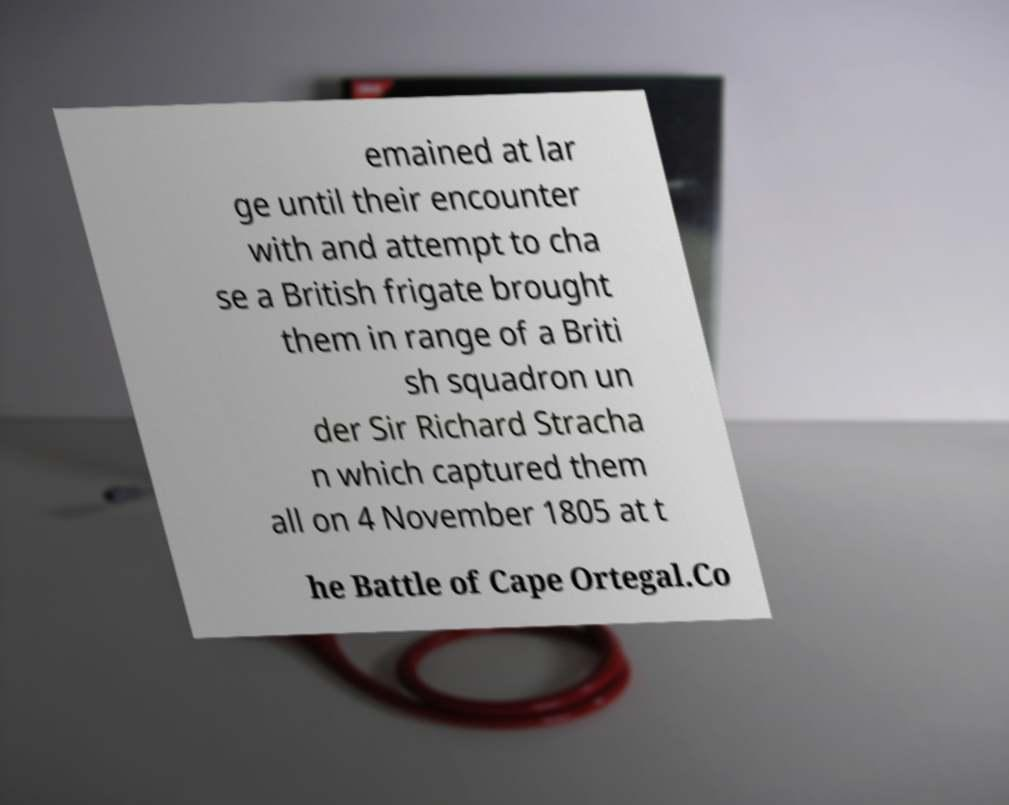Please read and relay the text visible in this image. What does it say? emained at lar ge until their encounter with and attempt to cha se a British frigate brought them in range of a Briti sh squadron un der Sir Richard Stracha n which captured them all on 4 November 1805 at t he Battle of Cape Ortegal.Co 